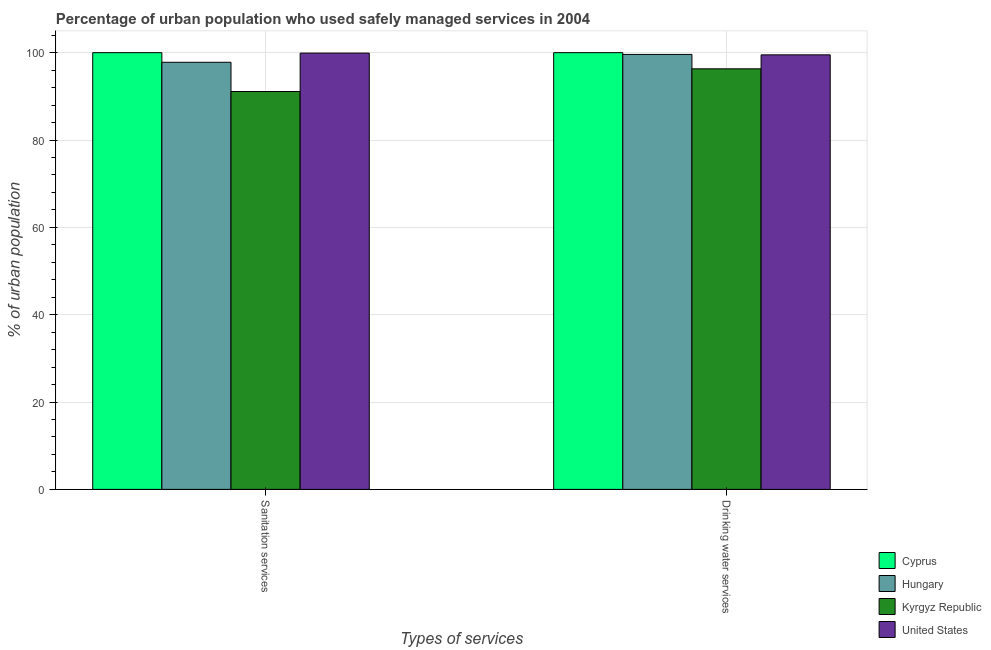How many groups of bars are there?
Keep it short and to the point. 2. Are the number of bars per tick equal to the number of legend labels?
Provide a succinct answer. Yes. Are the number of bars on each tick of the X-axis equal?
Provide a succinct answer. Yes. How many bars are there on the 1st tick from the left?
Provide a short and direct response. 4. How many bars are there on the 1st tick from the right?
Your answer should be compact. 4. What is the label of the 2nd group of bars from the left?
Provide a succinct answer. Drinking water services. What is the percentage of urban population who used drinking water services in Kyrgyz Republic?
Provide a short and direct response. 96.3. Across all countries, what is the minimum percentage of urban population who used drinking water services?
Offer a very short reply. 96.3. In which country was the percentage of urban population who used drinking water services maximum?
Your response must be concise. Cyprus. In which country was the percentage of urban population who used drinking water services minimum?
Your response must be concise. Kyrgyz Republic. What is the total percentage of urban population who used sanitation services in the graph?
Make the answer very short. 388.8. What is the difference between the percentage of urban population who used sanitation services in Hungary and that in Kyrgyz Republic?
Provide a short and direct response. 6.7. What is the average percentage of urban population who used drinking water services per country?
Provide a short and direct response. 98.85. What is the difference between the percentage of urban population who used drinking water services and percentage of urban population who used sanitation services in Cyprus?
Your answer should be very brief. 0. In how many countries, is the percentage of urban population who used sanitation services greater than 8 %?
Offer a terse response. 4. What is the ratio of the percentage of urban population who used sanitation services in Cyprus to that in Hungary?
Offer a terse response. 1.02. Is the percentage of urban population who used sanitation services in Kyrgyz Republic less than that in United States?
Your answer should be very brief. Yes. In how many countries, is the percentage of urban population who used drinking water services greater than the average percentage of urban population who used drinking water services taken over all countries?
Make the answer very short. 3. What does the 2nd bar from the left in Drinking water services represents?
Your answer should be very brief. Hungary. How many bars are there?
Your response must be concise. 8. Are all the bars in the graph horizontal?
Keep it short and to the point. No. What is the difference between two consecutive major ticks on the Y-axis?
Offer a very short reply. 20. Where does the legend appear in the graph?
Your answer should be compact. Bottom right. What is the title of the graph?
Give a very brief answer. Percentage of urban population who used safely managed services in 2004. What is the label or title of the X-axis?
Provide a short and direct response. Types of services. What is the label or title of the Y-axis?
Offer a very short reply. % of urban population. What is the % of urban population in Cyprus in Sanitation services?
Provide a short and direct response. 100. What is the % of urban population in Hungary in Sanitation services?
Offer a terse response. 97.8. What is the % of urban population of Kyrgyz Republic in Sanitation services?
Provide a short and direct response. 91.1. What is the % of urban population in United States in Sanitation services?
Your answer should be compact. 99.9. What is the % of urban population in Cyprus in Drinking water services?
Your answer should be very brief. 100. What is the % of urban population of Hungary in Drinking water services?
Your answer should be very brief. 99.6. What is the % of urban population of Kyrgyz Republic in Drinking water services?
Your answer should be very brief. 96.3. What is the % of urban population in United States in Drinking water services?
Offer a terse response. 99.5. Across all Types of services, what is the maximum % of urban population in Cyprus?
Offer a very short reply. 100. Across all Types of services, what is the maximum % of urban population in Hungary?
Offer a terse response. 99.6. Across all Types of services, what is the maximum % of urban population of Kyrgyz Republic?
Your response must be concise. 96.3. Across all Types of services, what is the maximum % of urban population of United States?
Keep it short and to the point. 99.9. Across all Types of services, what is the minimum % of urban population of Cyprus?
Provide a succinct answer. 100. Across all Types of services, what is the minimum % of urban population of Hungary?
Keep it short and to the point. 97.8. Across all Types of services, what is the minimum % of urban population in Kyrgyz Republic?
Your response must be concise. 91.1. Across all Types of services, what is the minimum % of urban population of United States?
Offer a very short reply. 99.5. What is the total % of urban population of Cyprus in the graph?
Give a very brief answer. 200. What is the total % of urban population of Hungary in the graph?
Keep it short and to the point. 197.4. What is the total % of urban population of Kyrgyz Republic in the graph?
Keep it short and to the point. 187.4. What is the total % of urban population in United States in the graph?
Provide a short and direct response. 199.4. What is the difference between the % of urban population in Cyprus in Sanitation services and that in Drinking water services?
Make the answer very short. 0. What is the difference between the % of urban population in Hungary in Sanitation services and that in Drinking water services?
Offer a very short reply. -1.8. What is the difference between the % of urban population of Kyrgyz Republic in Sanitation services and that in Drinking water services?
Provide a succinct answer. -5.2. What is the difference between the % of urban population of Cyprus in Sanitation services and the % of urban population of Hungary in Drinking water services?
Your answer should be compact. 0.4. What is the difference between the % of urban population of Cyprus in Sanitation services and the % of urban population of United States in Drinking water services?
Your answer should be very brief. 0.5. What is the difference between the % of urban population of Hungary in Sanitation services and the % of urban population of United States in Drinking water services?
Offer a terse response. -1.7. What is the difference between the % of urban population in Kyrgyz Republic in Sanitation services and the % of urban population in United States in Drinking water services?
Make the answer very short. -8.4. What is the average % of urban population in Cyprus per Types of services?
Ensure brevity in your answer.  100. What is the average % of urban population of Hungary per Types of services?
Give a very brief answer. 98.7. What is the average % of urban population in Kyrgyz Republic per Types of services?
Your response must be concise. 93.7. What is the average % of urban population of United States per Types of services?
Give a very brief answer. 99.7. What is the difference between the % of urban population in Cyprus and % of urban population in Hungary in Sanitation services?
Your answer should be very brief. 2.2. What is the difference between the % of urban population of Hungary and % of urban population of United States in Sanitation services?
Your answer should be compact. -2.1. What is the difference between the % of urban population in Cyprus and % of urban population in Hungary in Drinking water services?
Your response must be concise. 0.4. What is the difference between the % of urban population of Hungary and % of urban population of United States in Drinking water services?
Make the answer very short. 0.1. What is the difference between the % of urban population in Kyrgyz Republic and % of urban population in United States in Drinking water services?
Your answer should be compact. -3.2. What is the ratio of the % of urban population in Cyprus in Sanitation services to that in Drinking water services?
Provide a succinct answer. 1. What is the ratio of the % of urban population of Hungary in Sanitation services to that in Drinking water services?
Your response must be concise. 0.98. What is the ratio of the % of urban population of Kyrgyz Republic in Sanitation services to that in Drinking water services?
Your response must be concise. 0.95. What is the difference between the highest and the lowest % of urban population in Cyprus?
Your answer should be very brief. 0. What is the difference between the highest and the lowest % of urban population of Hungary?
Ensure brevity in your answer.  1.8. What is the difference between the highest and the lowest % of urban population of United States?
Your answer should be very brief. 0.4. 